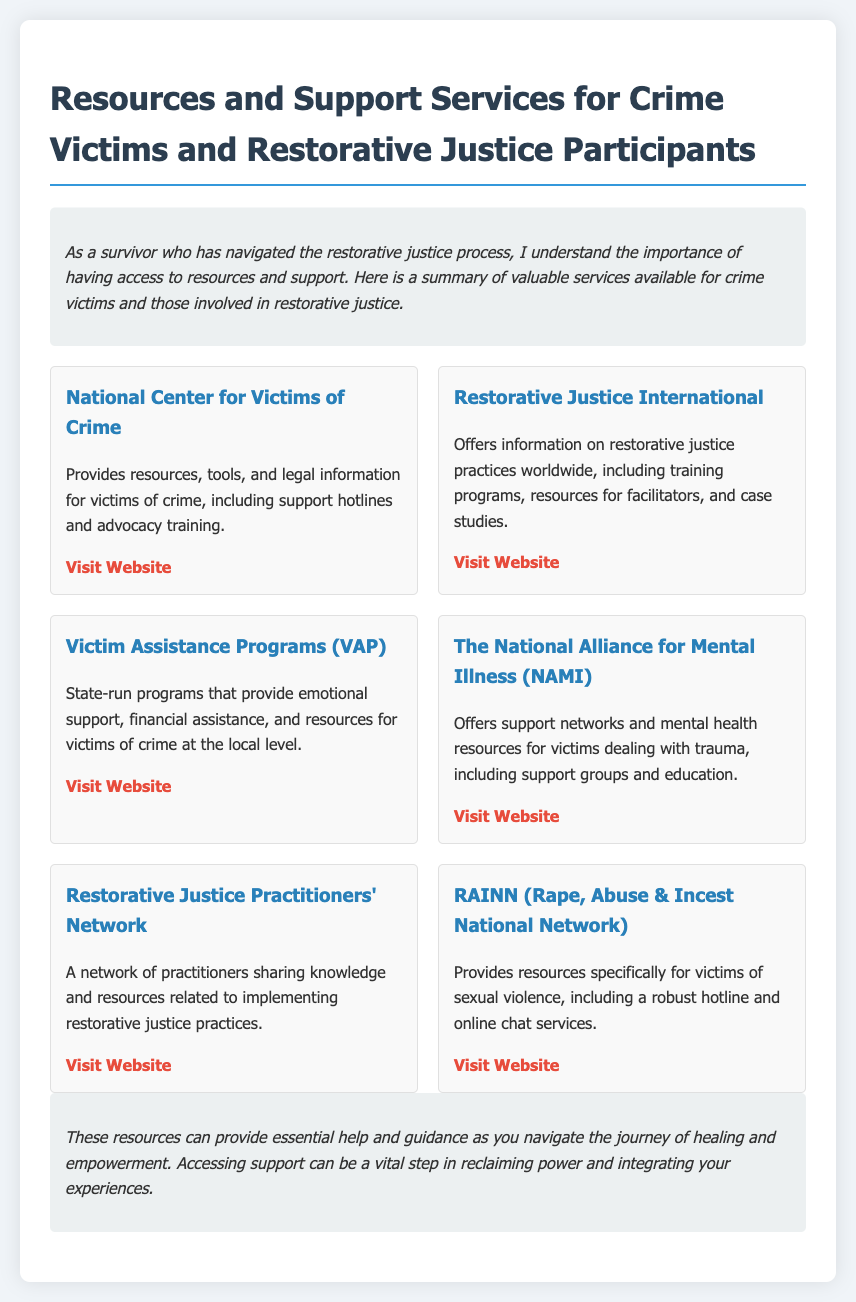What organization provides resources for crime victims? The National Center for Victims of Crime is mentioned as providing resources for crime victims.
Answer: National Center for Victims of Crime What type of support does NAMI offer? The National Alliance for Mental Illness offers support networks and mental health resources for victims dealing with trauma.
Answer: Support networks How many resources are listed in the document? There are six resources provided in the document for crime victims and restorative justice participants.
Answer: Six Which organization focuses specifically on sexual violence? RAINN, the Rape, Abuse & Incest National Network, specifically provides resources for sexual violence victims.
Answer: RAINN What type of programs does VAP offer? Victim Assistance Programs provide emotional support, financial assistance, and resources for victims of crime at the local level.
Answer: Emotional support What is a unique aspect of the Restorative Justice Practitioners' Network? The Restorative Justice Practitioners' Network is a network of practitioners sharing knowledge and resources related to implementing restorative justice practices.
Answer: Sharing knowledge 